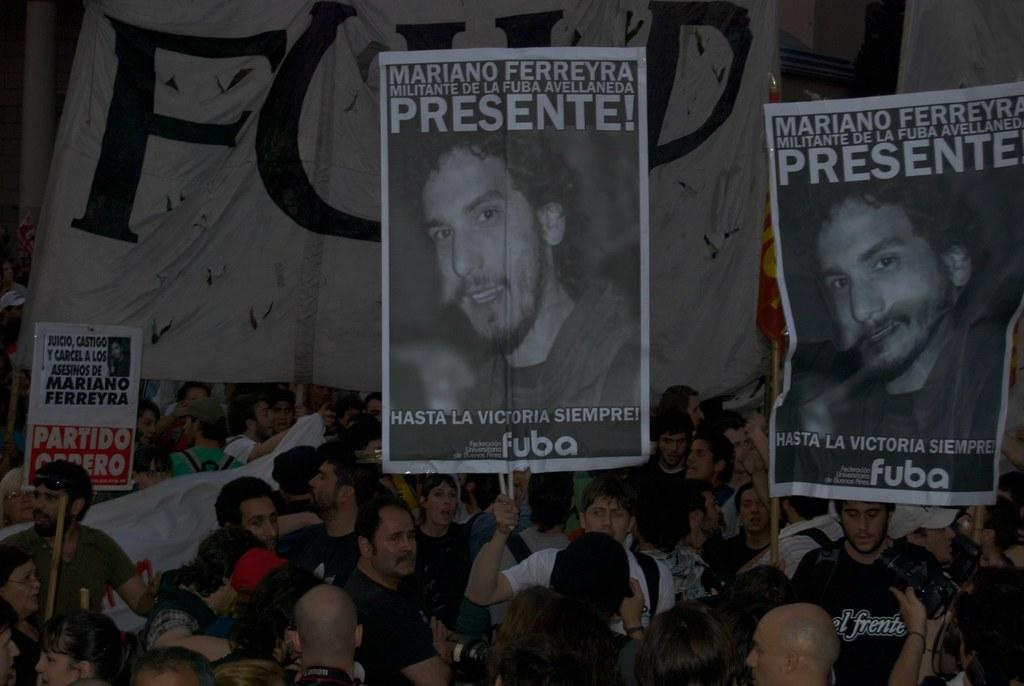How many people are in the image? There is a group of people in the image, but the exact number is not specified. What can be seen in the background of the image? There are posters and banners in the background of the image. What type of verse is written on the throne in the image? There is no throne present in the image, so it is not possible to answer that question. 